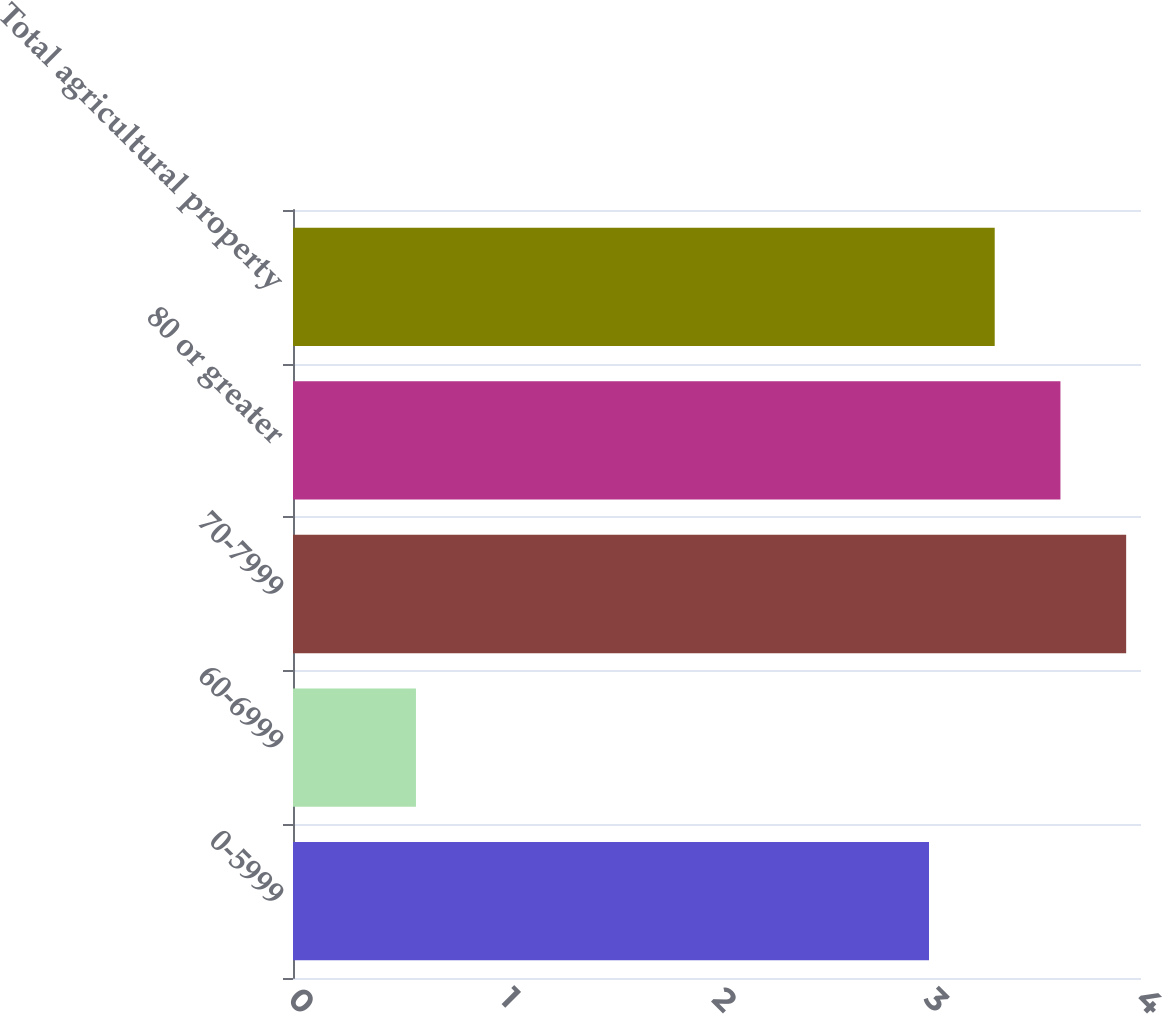Convert chart. <chart><loc_0><loc_0><loc_500><loc_500><bar_chart><fcel>0-5999<fcel>60-6999<fcel>70-7999<fcel>80 or greater<fcel>Total agricultural property<nl><fcel>3<fcel>0.58<fcel>3.93<fcel>3.62<fcel>3.31<nl></chart> 